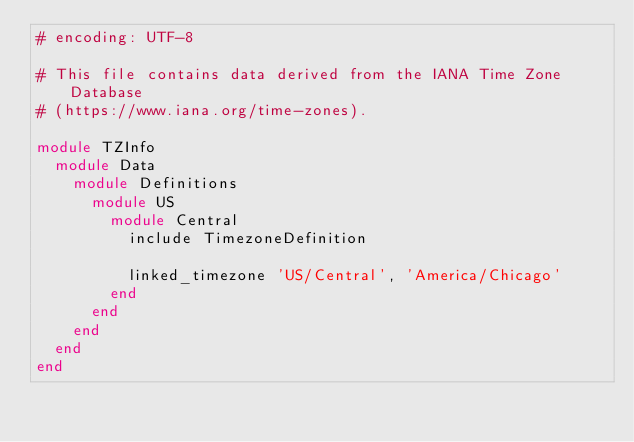<code> <loc_0><loc_0><loc_500><loc_500><_Ruby_># encoding: UTF-8

# This file contains data derived from the IANA Time Zone Database
# (https://www.iana.org/time-zones).

module TZInfo
  module Data
    module Definitions
      module US
        module Central
          include TimezoneDefinition
          
          linked_timezone 'US/Central', 'America/Chicago'
        end
      end
    end
  end
end
</code> 